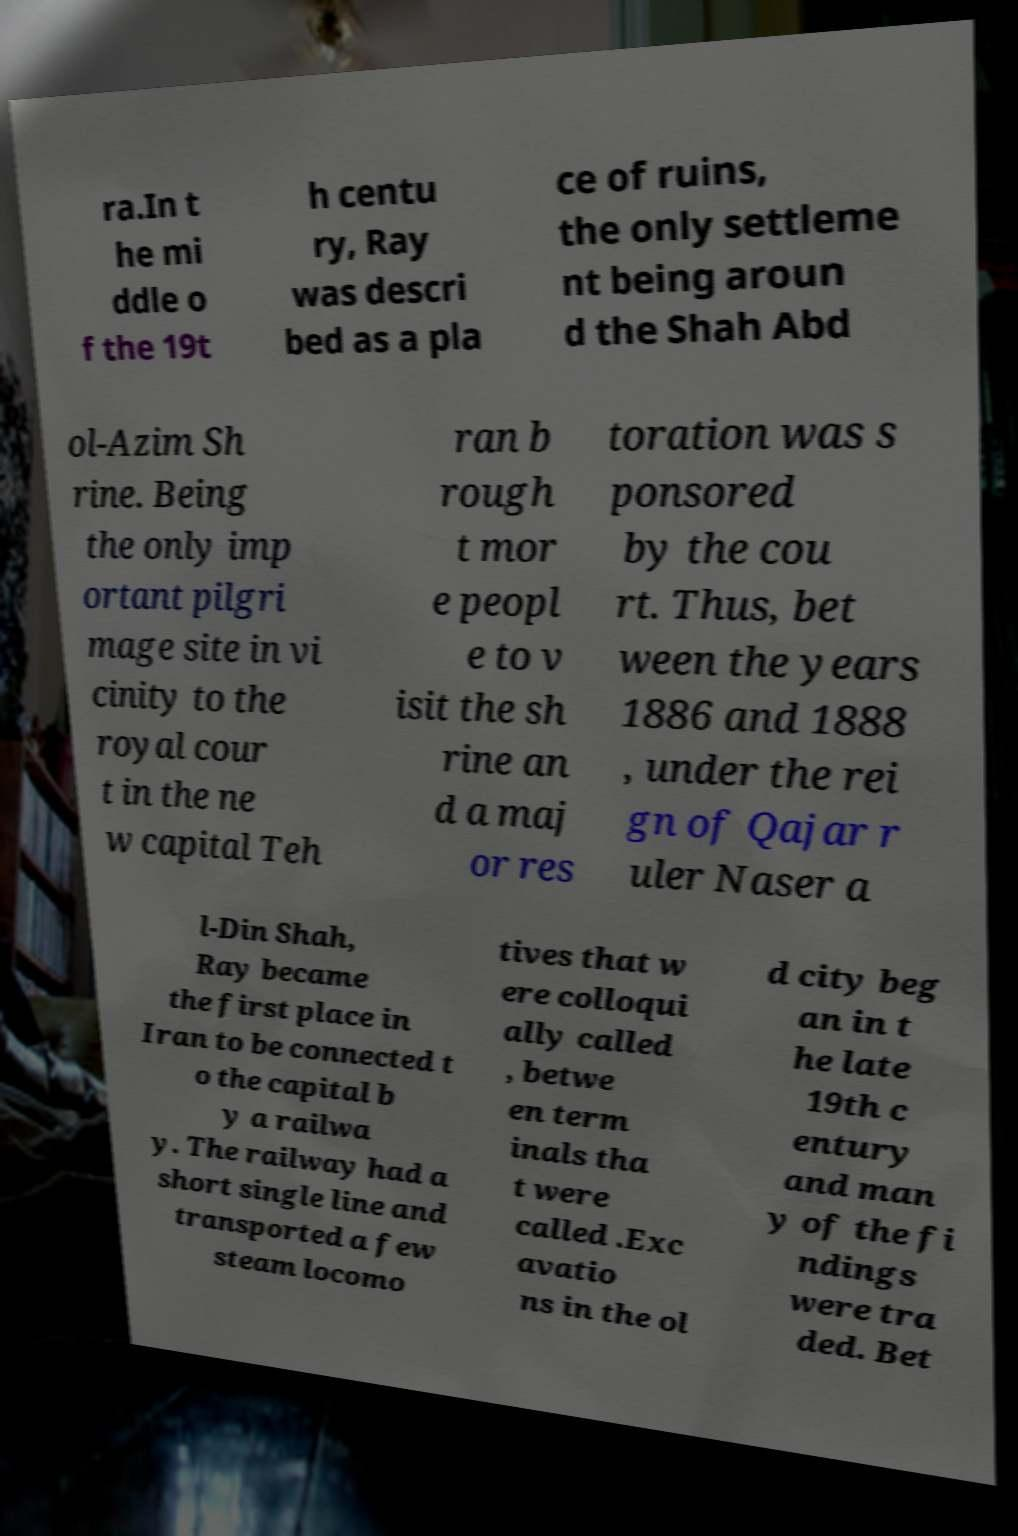Can you read and provide the text displayed in the image?This photo seems to have some interesting text. Can you extract and type it out for me? ra.In t he mi ddle o f the 19t h centu ry, Ray was descri bed as a pla ce of ruins, the only settleme nt being aroun d the Shah Abd ol-Azim Sh rine. Being the only imp ortant pilgri mage site in vi cinity to the royal cour t in the ne w capital Teh ran b rough t mor e peopl e to v isit the sh rine an d a maj or res toration was s ponsored by the cou rt. Thus, bet ween the years 1886 and 1888 , under the rei gn of Qajar r uler Naser a l-Din Shah, Ray became the first place in Iran to be connected t o the capital b y a railwa y. The railway had a short single line and transported a few steam locomo tives that w ere colloqui ally called , betwe en term inals tha t were called .Exc avatio ns in the ol d city beg an in t he late 19th c entury and man y of the fi ndings were tra ded. Bet 